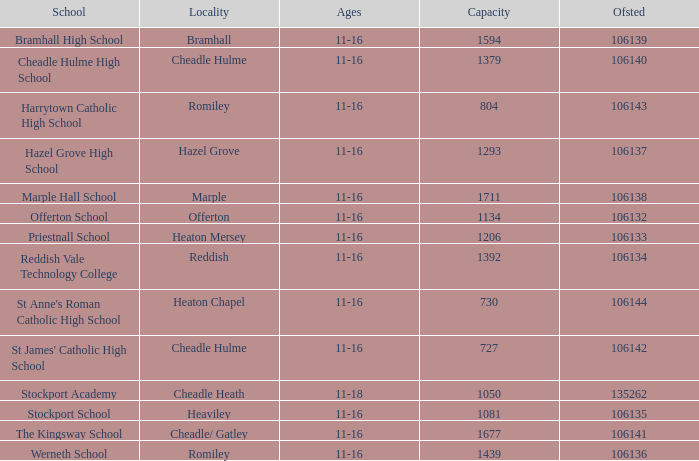Which ofsted includes marple hall school and supports more than 1711 students? None. 